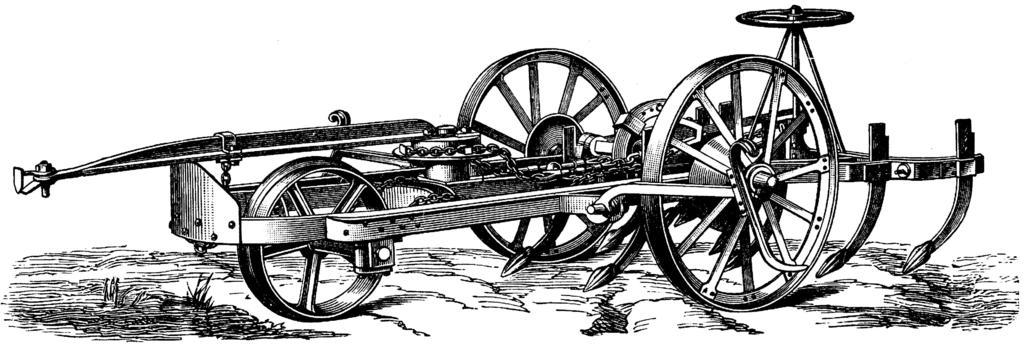What type of artwork is depicted in the image? The image is a painting. What object can be seen in the painting? There is a cart in the painting. How many geese are standing near the cart in the painting? There are no geese present in the painting; only a cart can be seen. Is there a cellar visible beneath the cart in the painting? There is no cellar visible in the painting; only the cart can be seen. 